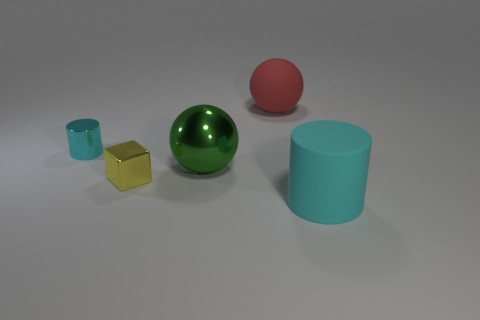What color is the matte thing that is behind the green object?
Make the answer very short. Red. The thing that is both left of the green object and right of the tiny metal cylinder is made of what material?
Provide a short and direct response. Metal. What number of large cyan objects are left of the cyan object that is right of the tiny yellow shiny thing?
Your answer should be very brief. 0. The small yellow shiny thing has what shape?
Offer a terse response. Cube. What shape is the red thing that is the same material as the large cyan object?
Offer a terse response. Sphere. Is the shape of the cyan thing that is on the left side of the yellow thing the same as  the green shiny object?
Keep it short and to the point. No. There is a cyan thing that is right of the metal cube; what is its shape?
Give a very brief answer. Cylinder. There is a large object that is the same color as the metallic cylinder; what shape is it?
Offer a very short reply. Cylinder. What number of other yellow cubes have the same size as the yellow block?
Offer a terse response. 0. What is the color of the metal cylinder?
Give a very brief answer. Cyan. 